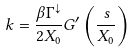<formula> <loc_0><loc_0><loc_500><loc_500>k = \frac { \beta \Gamma ^ { \downarrow } } { 2 X _ { 0 } } G ^ { \prime } \left ( \frac { s } { X _ { 0 } } \right )</formula> 